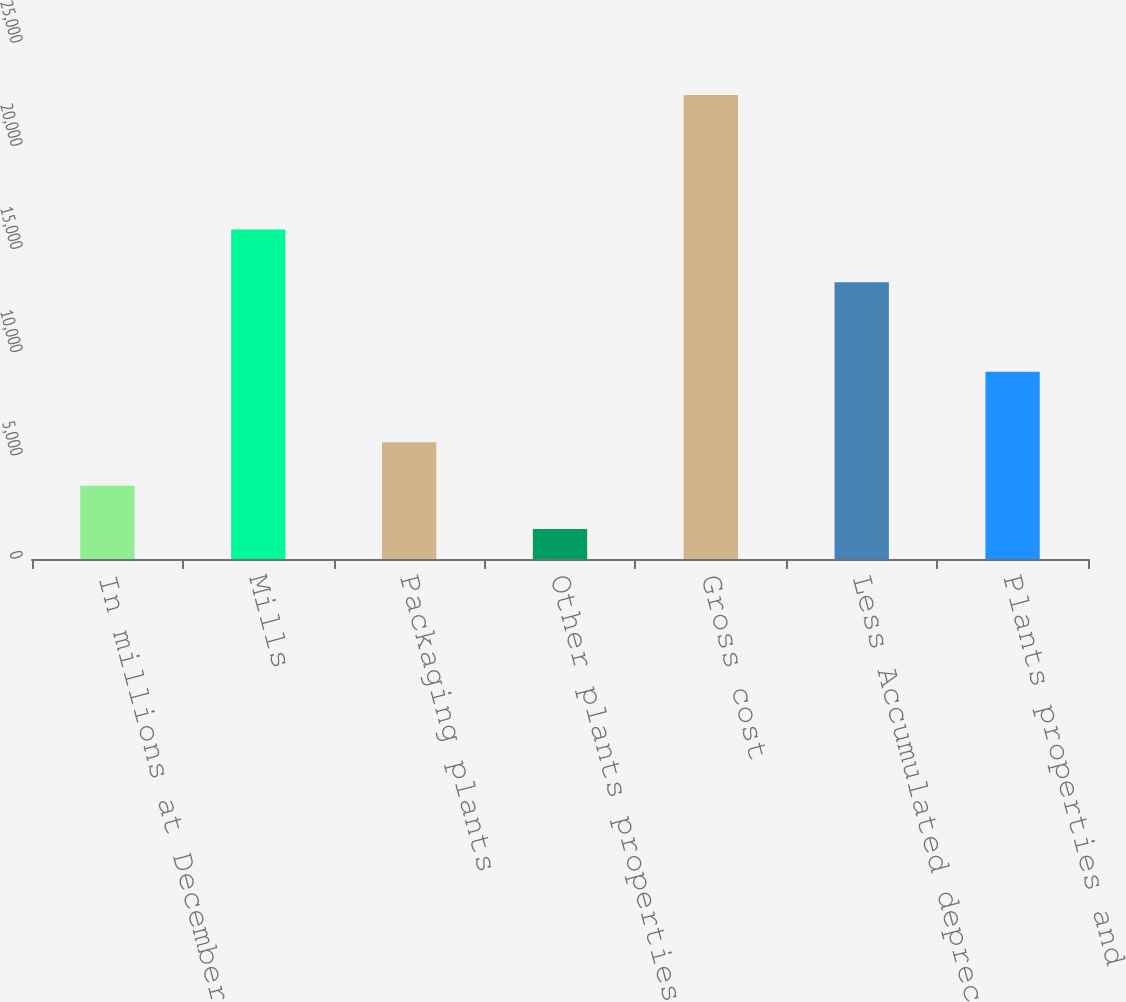Convert chart to OTSL. <chart><loc_0><loc_0><loc_500><loc_500><bar_chart><fcel>In millions at December 31<fcel>Mills<fcel>Packaging plants<fcel>Other plants properties and<fcel>Gross cost<fcel>Less Accumulated depreciation<fcel>Plants properties and<nl><fcel>3553.6<fcel>15968<fcel>5657.2<fcel>1450<fcel>22486<fcel>13413<fcel>9073<nl></chart> 